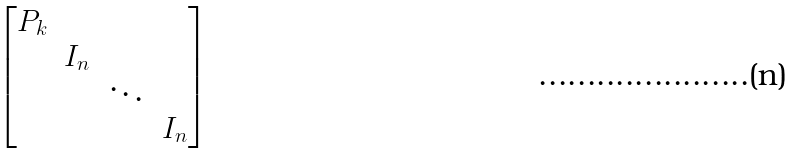<formula> <loc_0><loc_0><loc_500><loc_500>\begin{bmatrix} P _ { k } & & & \\ & I _ { n } & & \\ & & \ddots & \\ & & & I _ { n } \end{bmatrix}</formula> 